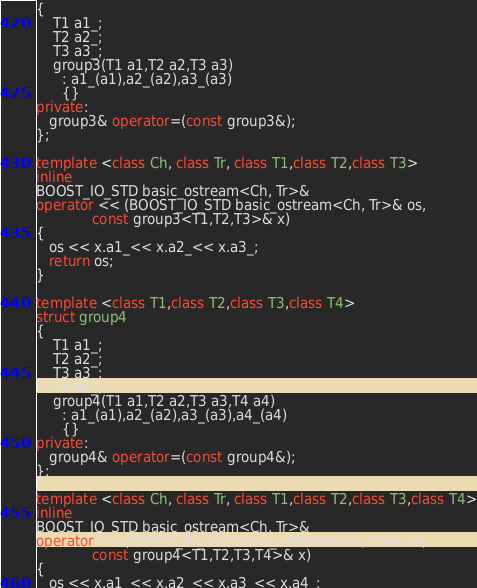<code> <loc_0><loc_0><loc_500><loc_500><_C++_>{
    T1 a1_;
    T2 a2_;
    T3 a3_;
    group3(T1 a1,T2 a2,T3 a3)
      : a1_(a1),a2_(a2),a3_(a3)
      {}
private:
   group3& operator=(const group3&);
};

template <class Ch, class Tr, class T1,class T2,class T3>
inline
BOOST_IO_STD basic_ostream<Ch, Tr>&
operator << (BOOST_IO_STD basic_ostream<Ch, Tr>& os,
             const group3<T1,T2,T3>& x)
{ 
   os << x.a1_<< x.a2_<< x.a3_;  
   return os; 
}

template <class T1,class T2,class T3,class T4>
struct group4
{
    T1 a1_;
    T2 a2_;
    T3 a3_;
    T4 a4_;
    group4(T1 a1,T2 a2,T3 a3,T4 a4)
      : a1_(a1),a2_(a2),a3_(a3),a4_(a4)
      {}
private:
   group4& operator=(const group4&);
};

template <class Ch, class Tr, class T1,class T2,class T3,class T4>
inline
BOOST_IO_STD basic_ostream<Ch, Tr>&
operator << (BOOST_IO_STD basic_ostream<Ch, Tr>& os,
             const group4<T1,T2,T3,T4>& x)
{ 
   os << x.a1_<< x.a2_<< x.a3_<< x.a4_;  </code> 